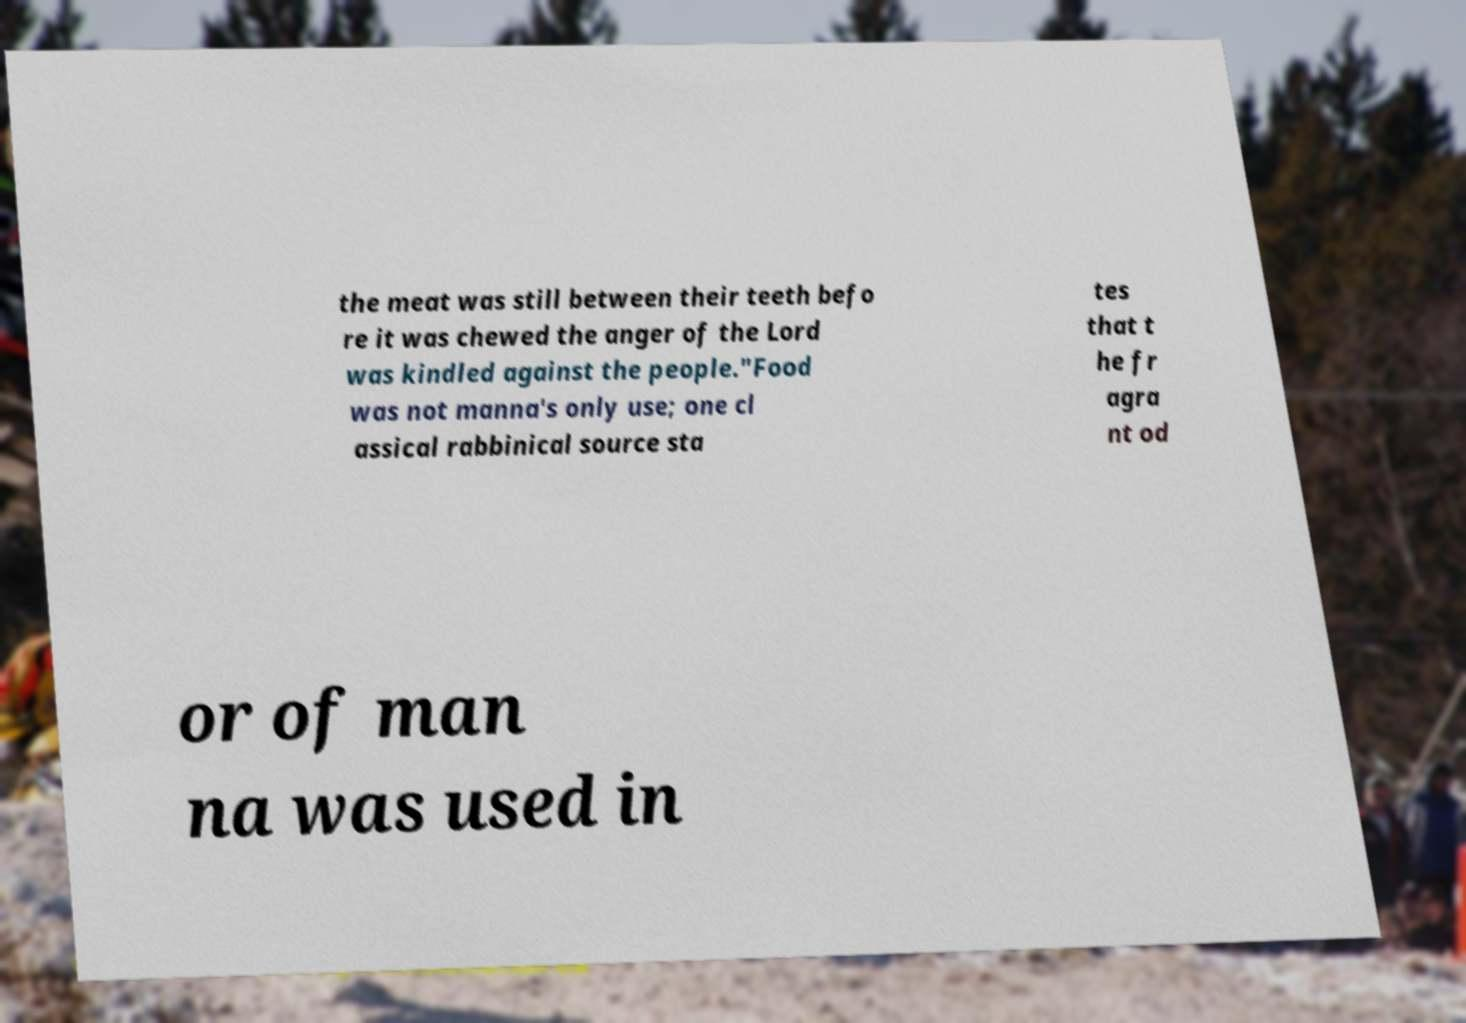What messages or text are displayed in this image? I need them in a readable, typed format. the meat was still between their teeth befo re it was chewed the anger of the Lord was kindled against the people."Food was not manna's only use; one cl assical rabbinical source sta tes that t he fr agra nt od or of man na was used in 